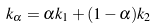Convert formula to latex. <formula><loc_0><loc_0><loc_500><loc_500>k _ { \alpha } = \alpha k _ { 1 } + ( 1 - \alpha ) k _ { 2 }</formula> 